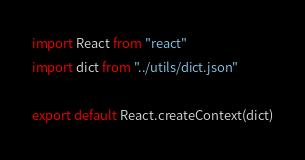<code> <loc_0><loc_0><loc_500><loc_500><_JavaScript_>import React from "react"
import dict from "../utils/dict.json"

export default React.createContext(dict)
</code> 